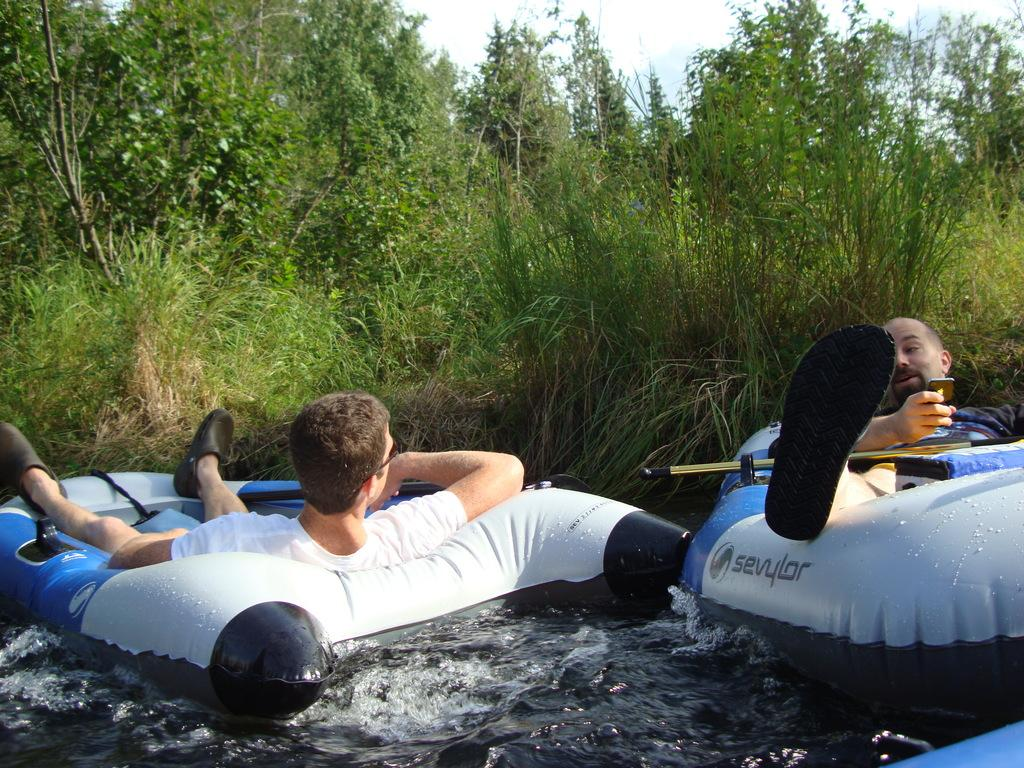What objects are present in the image that are filled with water? There are water balloons in the image. How many people can be seen in the image? There are persons in the image. What is the natural environment like in the image? There are trees and plants visible in the image. What can be seen in the sky in the image? The sky is visible in the image, and clouds are present. How do the tomatoes increase in size in the image? There are no tomatoes present in the image, so their size cannot be determined. 